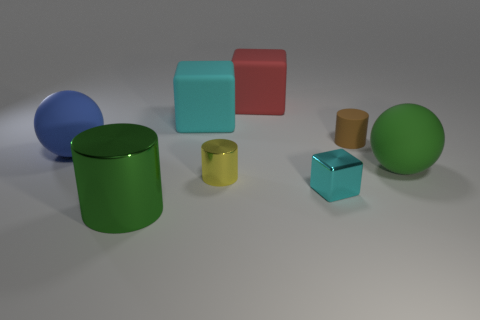Add 2 brown balls. How many objects exist? 10 Subtract all large blocks. How many blocks are left? 1 Subtract all green spheres. How many cyan cubes are left? 2 Subtract all red cubes. How many cubes are left? 2 Add 4 large cyan matte cubes. How many large cyan matte cubes exist? 5 Subtract 2 cyan blocks. How many objects are left? 6 Subtract all cubes. How many objects are left? 5 Subtract 1 cylinders. How many cylinders are left? 2 Subtract all yellow spheres. Subtract all cyan blocks. How many spheres are left? 2 Subtract all large cubes. Subtract all tiny matte spheres. How many objects are left? 6 